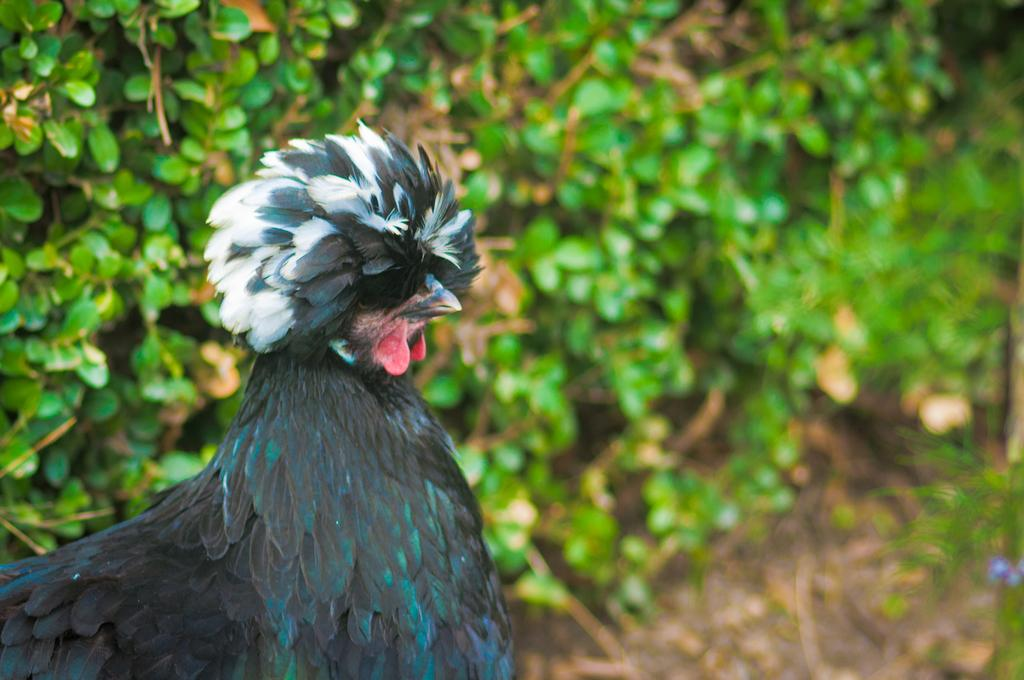What animal is present in the image? There is a hen in the image. Where is the hen located in the image? The hen is on the left side of the image. What can be seen in the background of the image? There is greenery in the background of the image. What type of haircut does the hen have in the image? The hen does not have a haircut, as it is a bird and does not have hair. 